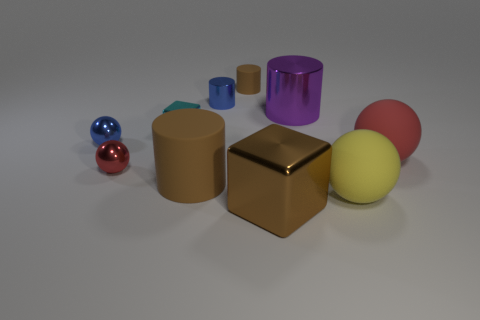Subtract all cylinders. How many objects are left? 6 Subtract 0 cyan balls. How many objects are left? 10 Subtract all cyan metal blocks. Subtract all purple metallic cylinders. How many objects are left? 8 Add 1 big rubber balls. How many big rubber balls are left? 3 Add 7 cyan metal cubes. How many cyan metal cubes exist? 8 